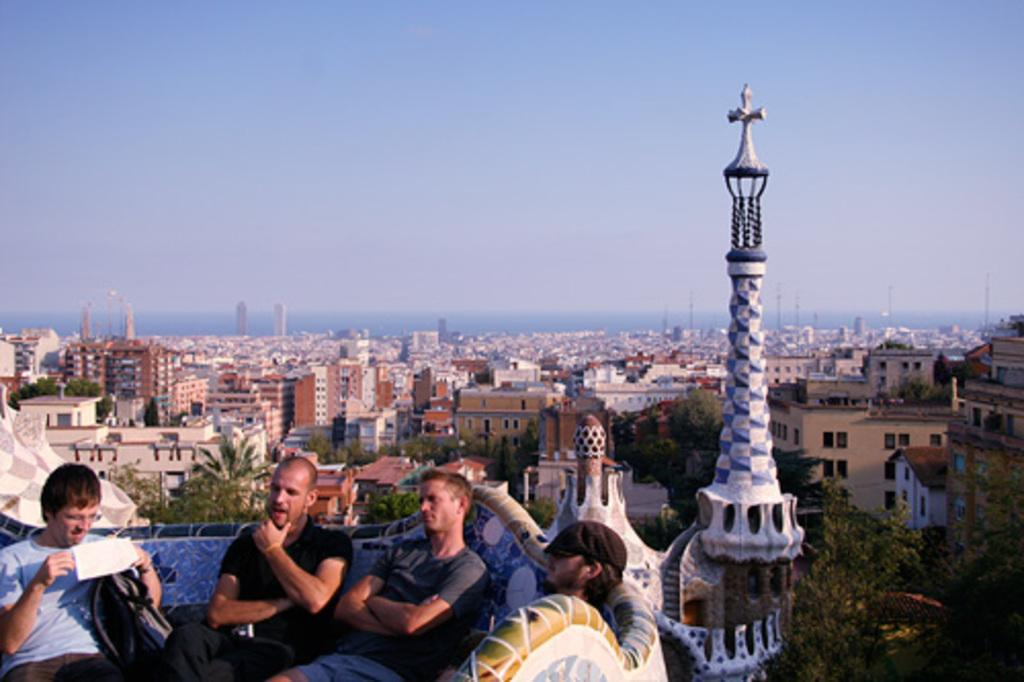What are the people in the image doing? There are persons sitting on the sofa in the image. What can be seen in the background of the image? There are buildings, trees, and the sky visible in the background of the image. Can you see any apples on the scarf that the person on the hill is wearing in the image? There is no hill, person wearing a scarf, or apple present in the image. 